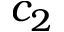<formula> <loc_0><loc_0><loc_500><loc_500>c _ { 2 }</formula> 